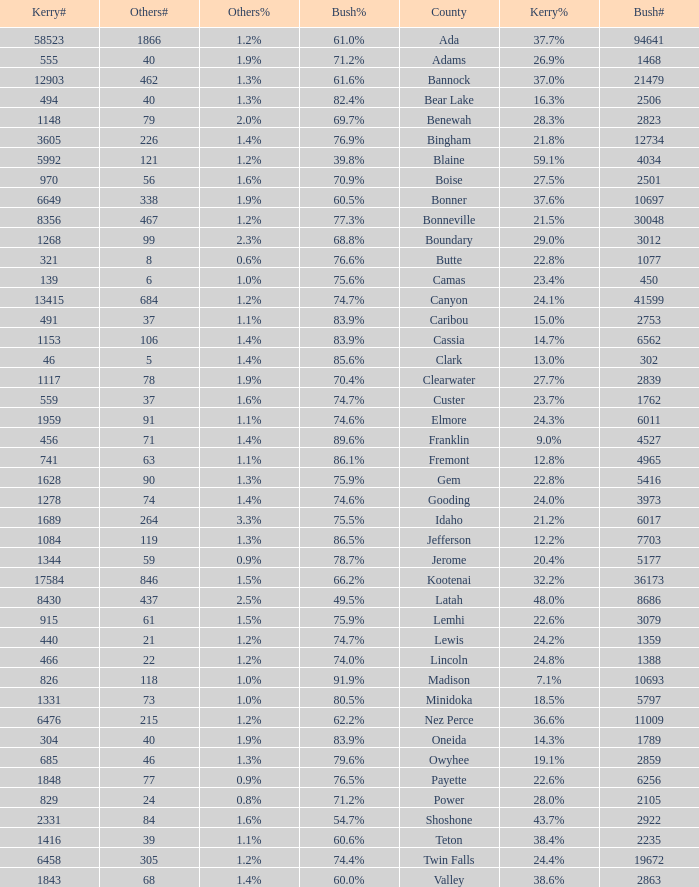How many people voted for Kerry in the county where 8 voted for others? 321.0. 